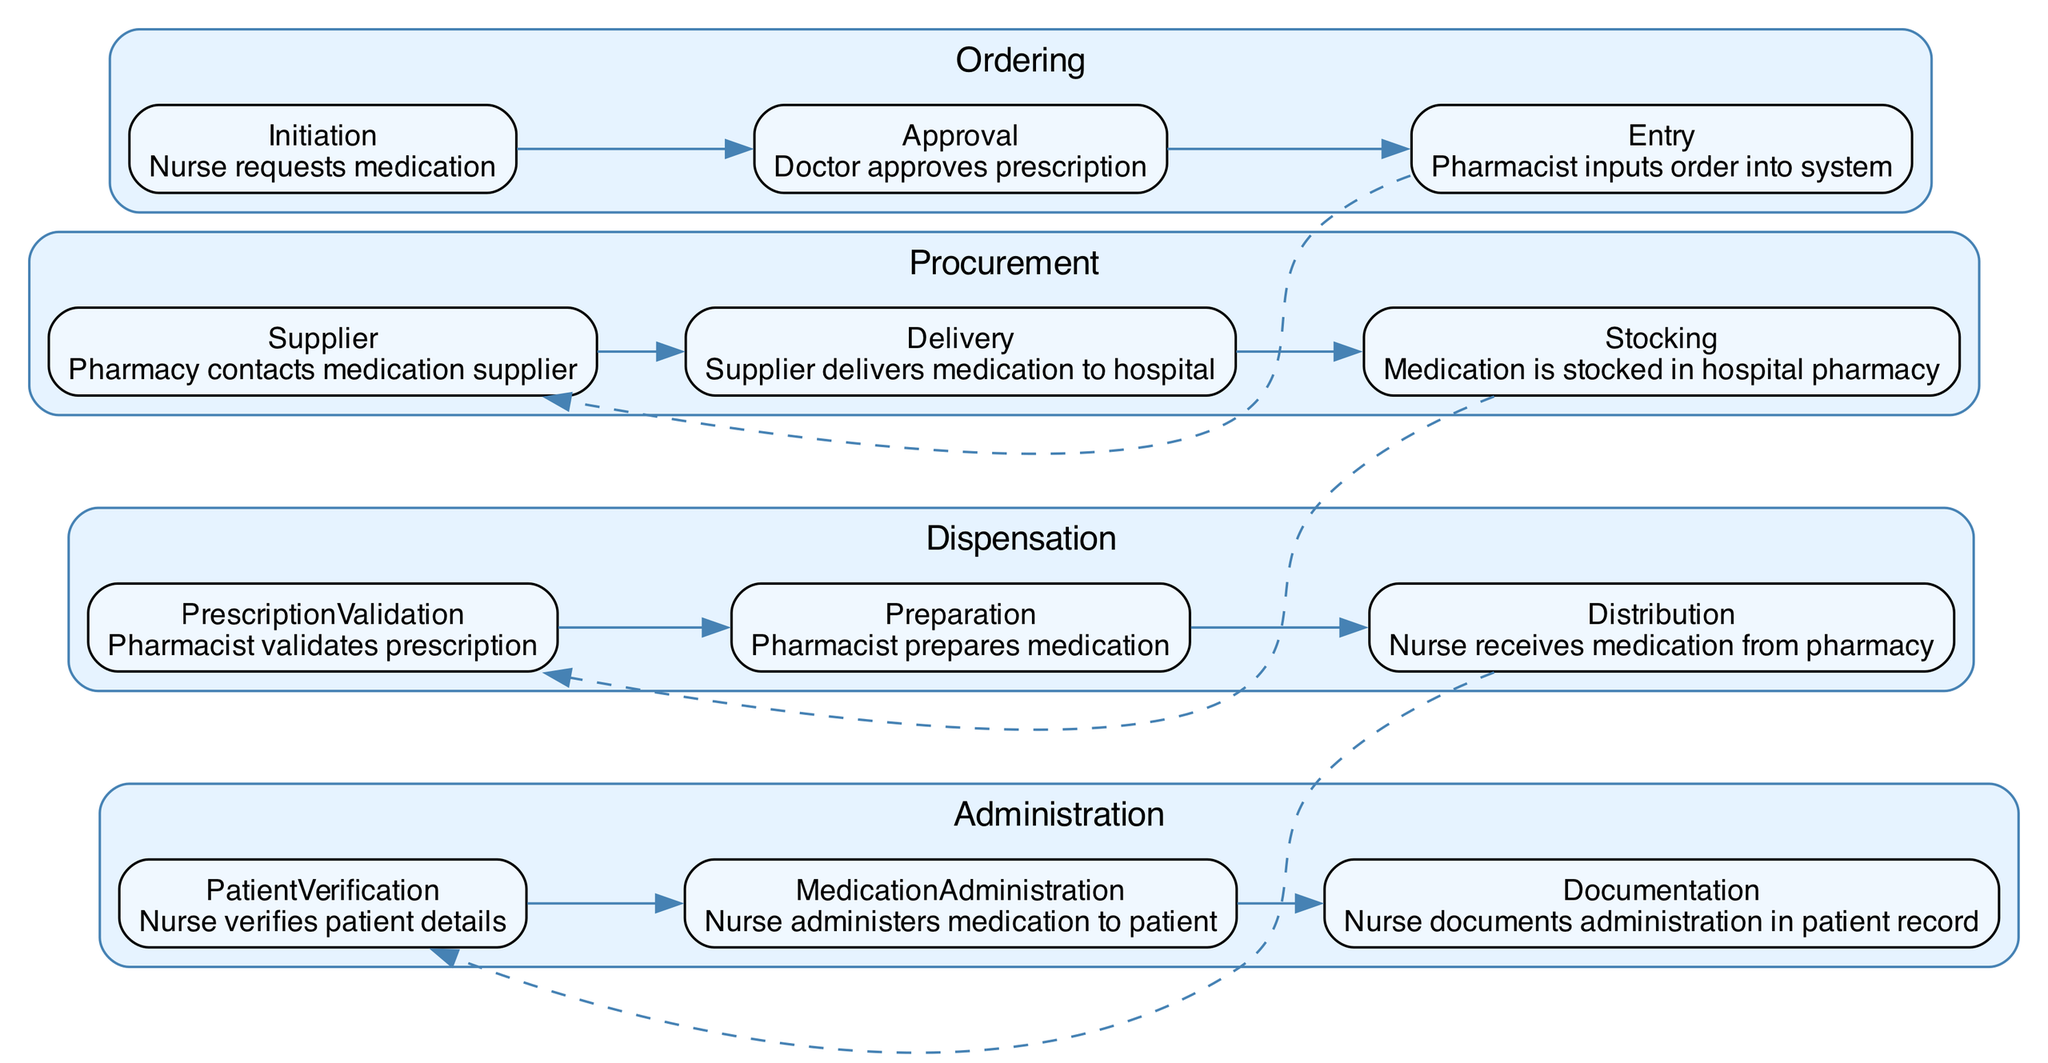What is the first step in the ordering stage? The first step in the ordering stage is the nurse requesting medication, as indicated by the 'Initiation' node in the diagram.
Answer: Nurse requests medication How many processes are there in the procurement stage? In the procurement stage, there are three processes: 'Supplier', 'Delivery', and 'Stocking'. Therefore, the total is three processes in this stage.
Answer: 3 What connects the 'Preparation' process to the 'Distribution' process? The 'Preparation' process connects to the 'Distribution' process directly within the dispensation stage as they are sequential processes. According to the diagram, there is an edge (line) that represents this connection.
Answer: Edge What is the last process in the administration stage? The last process in the administration stage is 'Documentation', as shown in the diagram under the administration section.
Answer: Documentation Which role is responsible for verifying patient details? The role responsible for verifying patient details is the nurse, as indicated in the 'PatientVerification' process of the administration stage.
Answer: Nurse How many main stages are represented in the medication supply chain? There are four main stages represented in the medication supply chain: 'Ordering', 'Procurement', 'Dispensation', and 'Administration'. This is a clear view from the subgraphs in the diagram.
Answer: 4 What process follows 'Delivery' in the procurement stage? The process that follows 'Delivery' in the procurement stage is 'Stocking', according to the sequential flow shown in the diagram.
Answer: Stocking What type of edge connects the last process of the 'Dispensation' with the first process of 'Administration'? The type of edge connecting the last process of 'Dispensation', which is 'Distribution', to the first process of 'Administration', which is 'PatientVerification', is a dashed edge, indicating a less direct connection than the usual flow.
Answer: Dashed edge In total, how many processes are present in the entire supply chain? The total number of processes present in the entire supply chain can be calculated by summing the processes in all stages: 3 (ordering) + 3 (procurement) + 3 (dispensation) + 3 (administration) equals 12 processes in total.
Answer: 12 